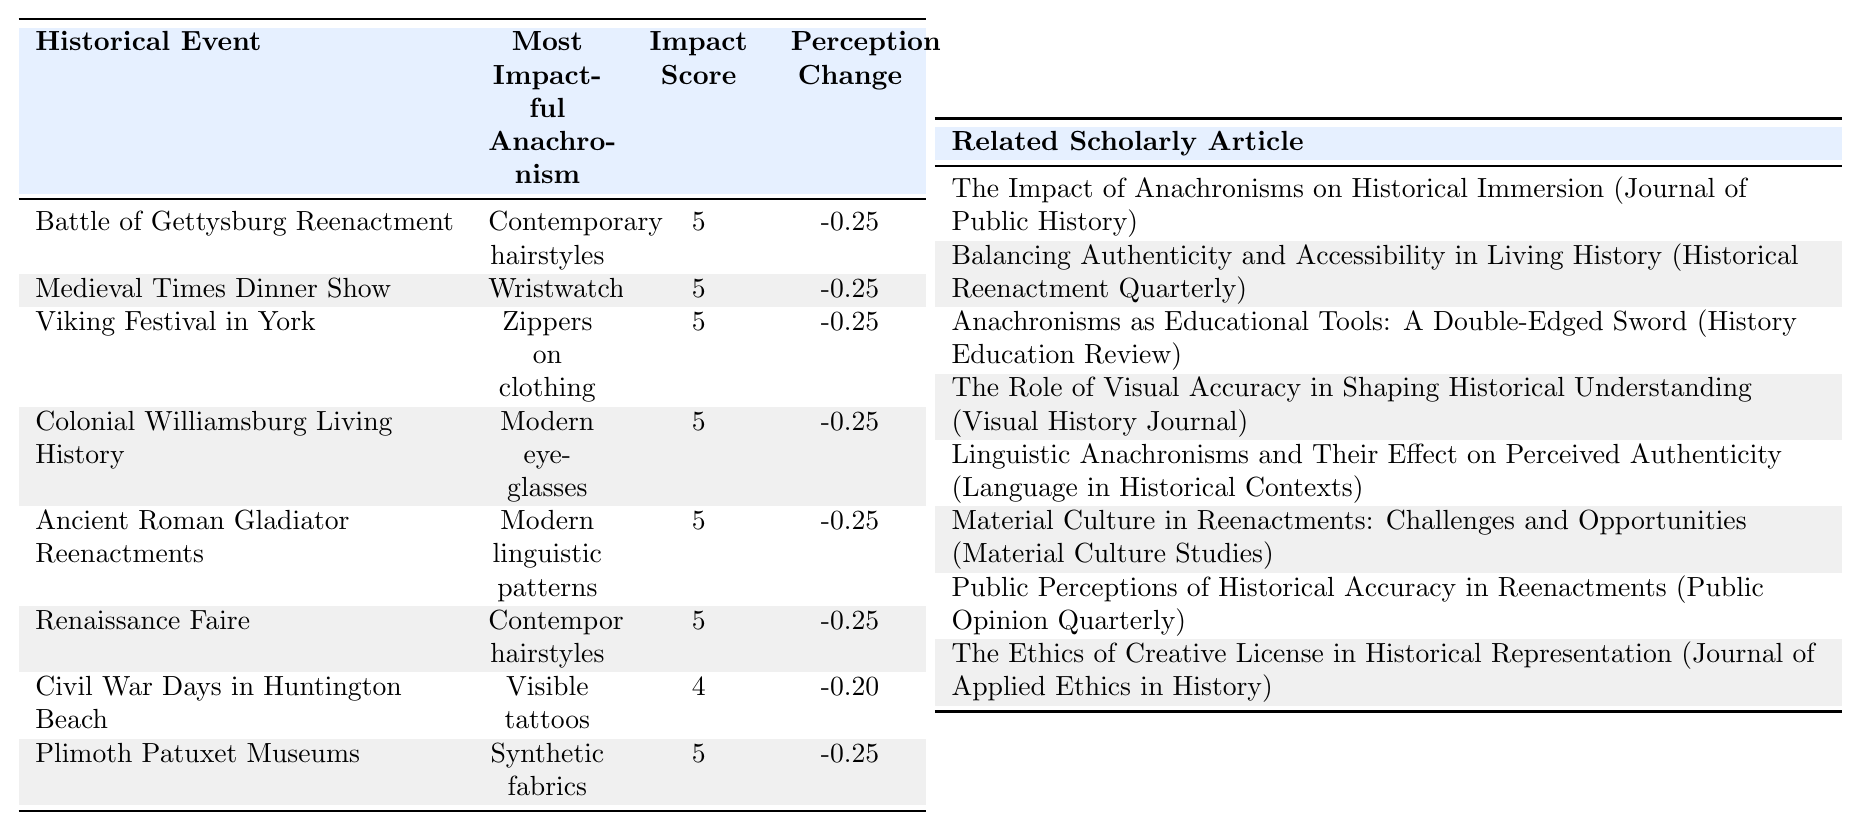What is the most impactful anachronism in the Battle of Gettysburg Reenactment? According to the table, the most impactful anachronism for the Battle of Gettysburg Reenactment is "Contemporary hairstyles" with an impact score of 5.
Answer: Contemporary hairstyles Which historical event has the highest impact score for anachronisms? The table shows that multiple events have the highest impact score of 5, including the Battle of Gettysburg Reenactment, Colonial Williamsburg Living History, Ancient Roman Gladiator Reenactments, Renaissance Faire, and Plimoth Patuxet Museums.
Answer: Multiple events (5 scores) What is the average perception change for the Medieval Times Dinner Show? The perception change values for the Medieval Times Dinner Show are given as follows: -0.20, -0.25, -0.15, -0.10, -0.05, -0.15, -0.20, -0.15 (8 data points). The average is calculated as (-0.20 -0.25 -0.15 -0.10 -0.05 -0.15 -0.20 -0.15) / 8 = -0.145.
Answer: -0.145 True or false: The Viking Festival in York has the same most impactful anachronism as the Renaissance Faire. The table indicates that the Viking Festival in York's most impactful anachronism is "Zippers on clothing," while the Renaissance Faire's is "Contemporary hairstyles." Since these are different, the statement is false.
Answer: False What is the difference in perception change between the Civil War Days and the Battle of Gettysburg Reenactment? The perception change for Civil War Days is -0.20, and for the Battle of Gettysburg Reenactment is -0.25. The difference is calculated as -0.20 - (-0.25) = 0.05.
Answer: 0.05 Which event had the lowest impact score rated by anachronisms? By examining the table, the Ancient Roman Gladiator Reenactments is shown to have the lowest impact score of 1 for the anachronisms "Modern linguistic patterns."
Answer: Ancient Roman Gladiator Reenactments Identify the historical event with the second highest perception change and explain its significance. The event with the second highest perception change is the Civil War Days at -0.20. This suggests a notable decrease in public perception regarding historical accuracy, likely due to identified anachronisms which could distort the narrative.
Answer: Civil War Days How many events resulted in a perception change greater than -0.2? By reviewing the perception change figures, it's noted that Civil War Days, Viking Festival, and the Medieval Times Dinner Show each have a perception change of -0.20 or worse, totaling three events.
Answer: 3 What is the combined impact score of the events that have "Modern eyeglasses" as their most impactful anachronism? The table shows two events where "Modern eyeglasses" has an impact score: Colonial Williamsburg Living History and Battle of Gettysburg Reenactment, both scoring 5. The combined score is 5 + 5 = 10.
Answer: 10 What is the average impact score for events featuring "synthetic fabrics" as an anachronism? There is one event, Plimoth Patuxet Museums, with an impact score of 5 for "Synthetic fabrics." As there is only one event, the average is simply 5.
Answer: 5 Which anachronism has the most negative average perception change across all events? The anachronism "Contemporary hairstyles" across events had a perception change that can be summarized as: (-0.25, -0.25, -0.25, -0.25, -0.25). Adding these: 5 terms of -0.25 yields a total of -1.25, and its average is -1.25 / 5 = -0.25.
Answer: Contemporary hairstyles 